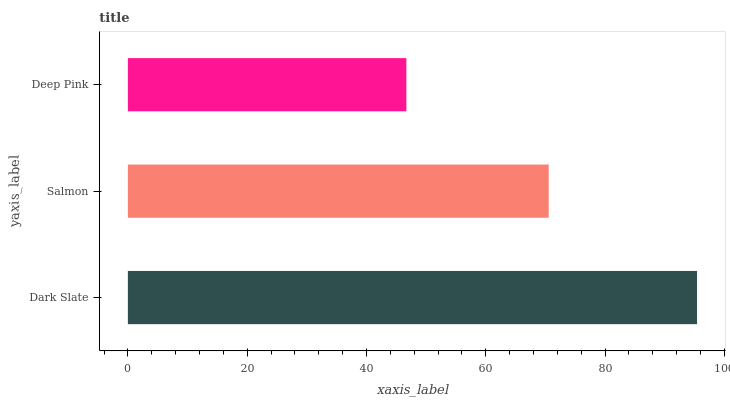Is Deep Pink the minimum?
Answer yes or no. Yes. Is Dark Slate the maximum?
Answer yes or no. Yes. Is Salmon the minimum?
Answer yes or no. No. Is Salmon the maximum?
Answer yes or no. No. Is Dark Slate greater than Salmon?
Answer yes or no. Yes. Is Salmon less than Dark Slate?
Answer yes or no. Yes. Is Salmon greater than Dark Slate?
Answer yes or no. No. Is Dark Slate less than Salmon?
Answer yes or no. No. Is Salmon the high median?
Answer yes or no. Yes. Is Salmon the low median?
Answer yes or no. Yes. Is Deep Pink the high median?
Answer yes or no. No. Is Deep Pink the low median?
Answer yes or no. No. 